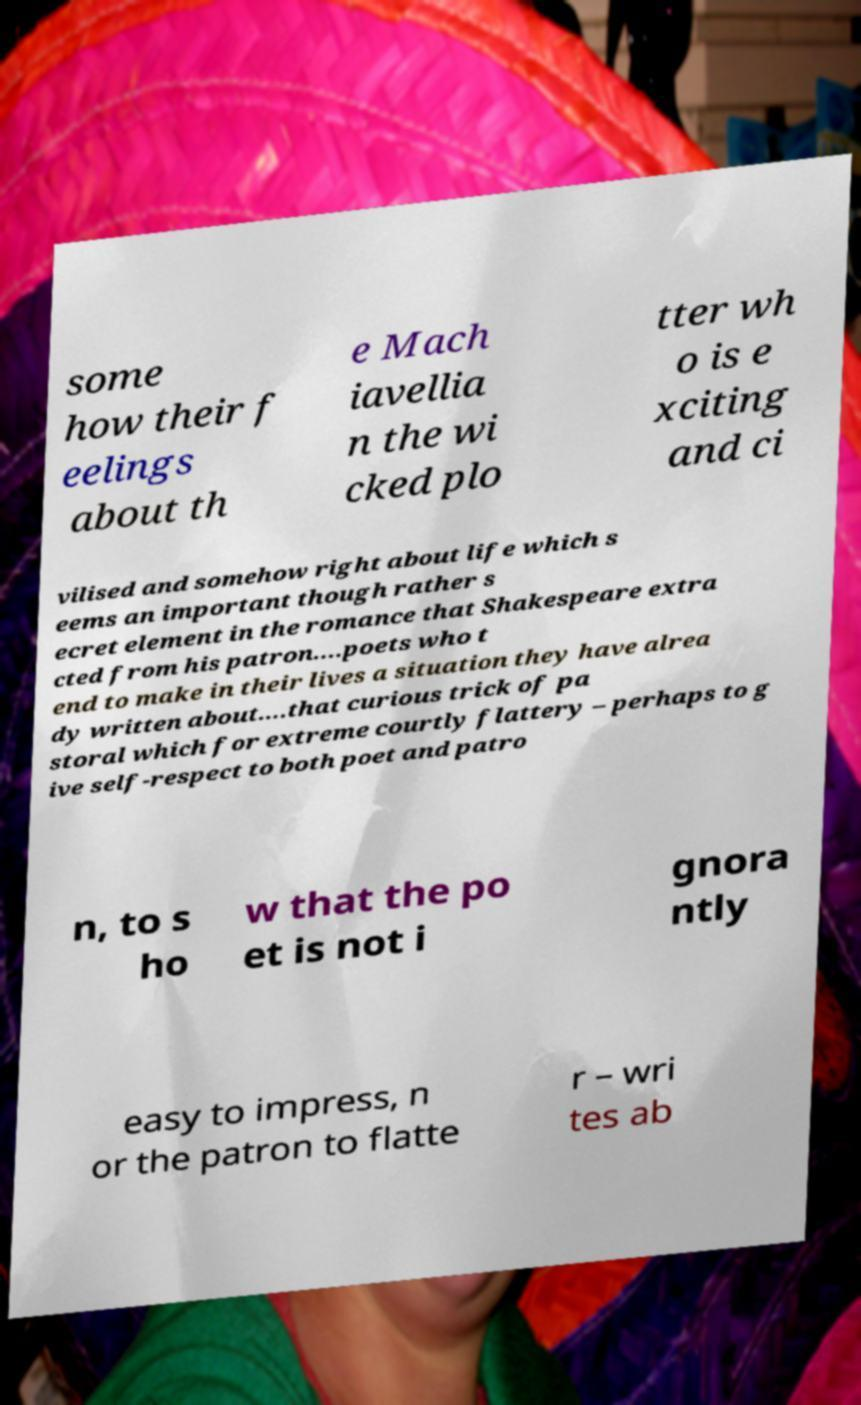Please read and relay the text visible in this image. What does it say? some how their f eelings about th e Mach iavellia n the wi cked plo tter wh o is e xciting and ci vilised and somehow right about life which s eems an important though rather s ecret element in the romance that Shakespeare extra cted from his patron....poets who t end to make in their lives a situation they have alrea dy written about....that curious trick of pa storal which for extreme courtly flattery – perhaps to g ive self-respect to both poet and patro n, to s ho w that the po et is not i gnora ntly easy to impress, n or the patron to flatte r – wri tes ab 